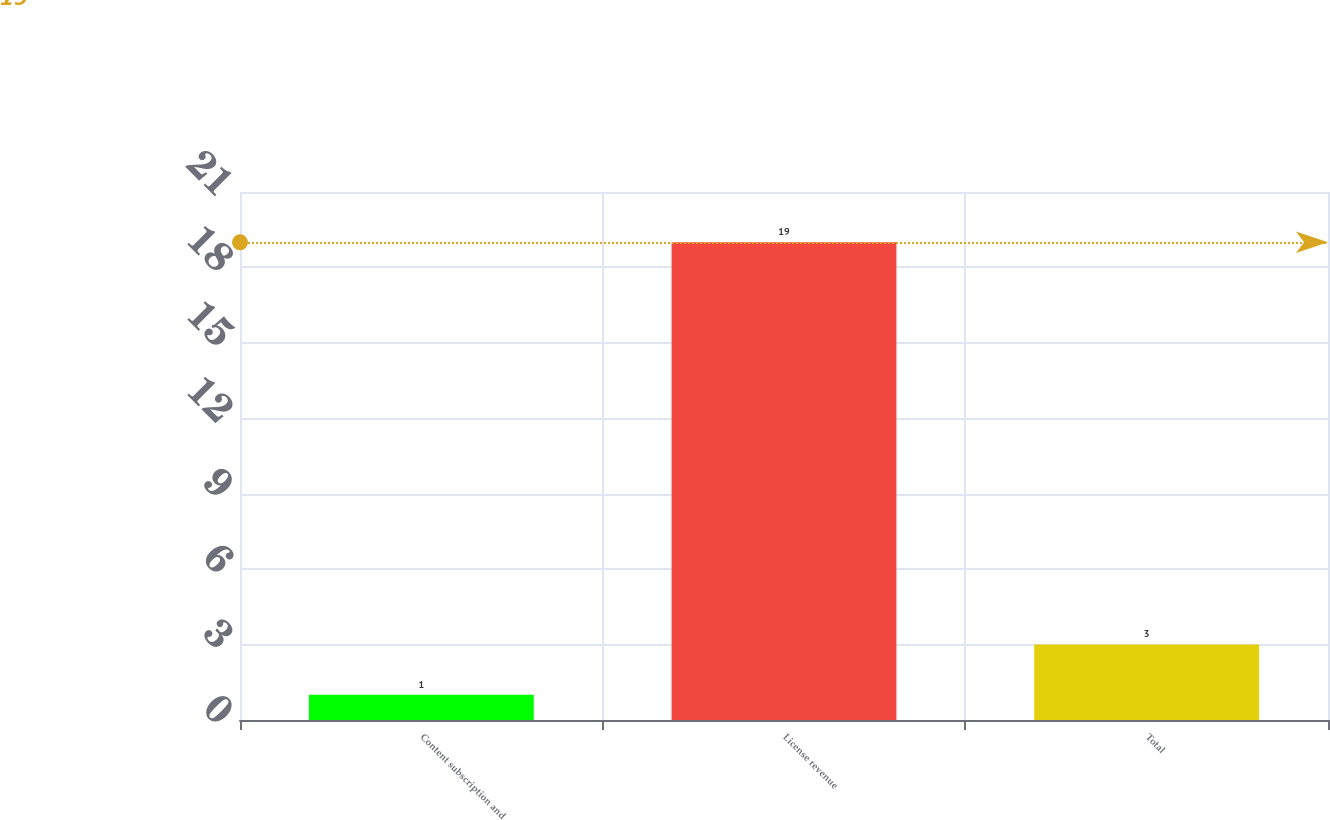<chart> <loc_0><loc_0><loc_500><loc_500><bar_chart><fcel>Content subscription and<fcel>License revenue<fcel>Total<nl><fcel>1<fcel>19<fcel>3<nl></chart> 